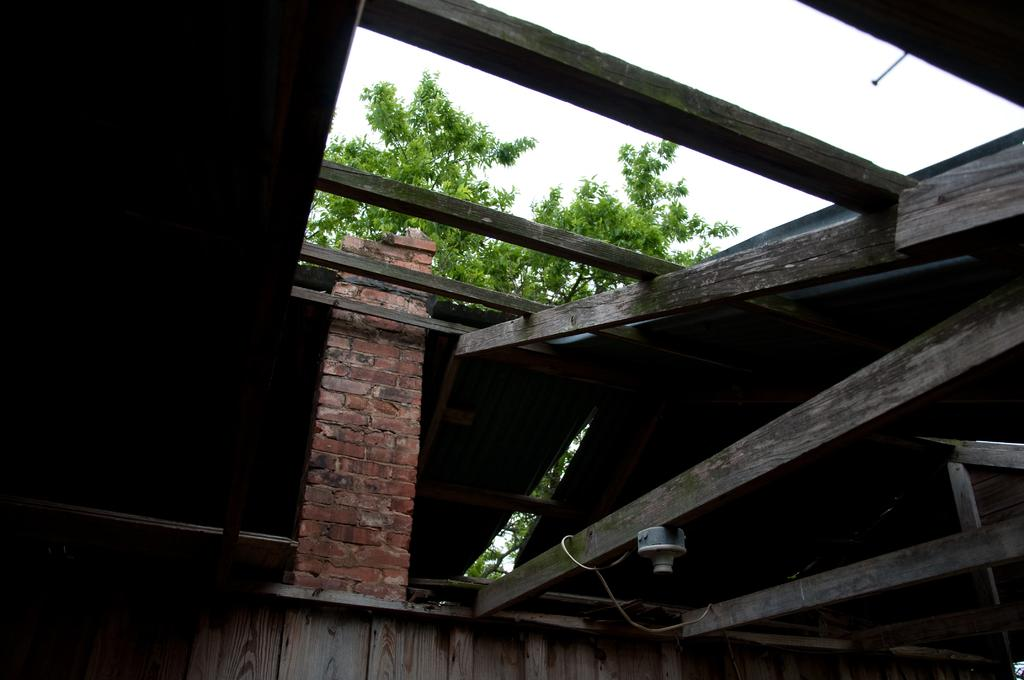What type of material is used for the poles in the image? The wooden poles are made of wood. What other structure can be seen in the image? There is a wooden wall in the image. What is the material of the pillar in the image? The pillar is made of brick. What can be seen behind the wooden poles? There is a tree visible behind the wooden poles. What is visible at the top of the image? The sky is visible in the image. How many frogs are sitting on the wooden poles in the image? There are no frogs present in the image; it features wooden poles, a wooden wall, a brick pillar, a tree, and the sky. What type of fruit is hanging from the tree in the image? There is no fruit visible on the tree in the image; only the tree itself is present. 